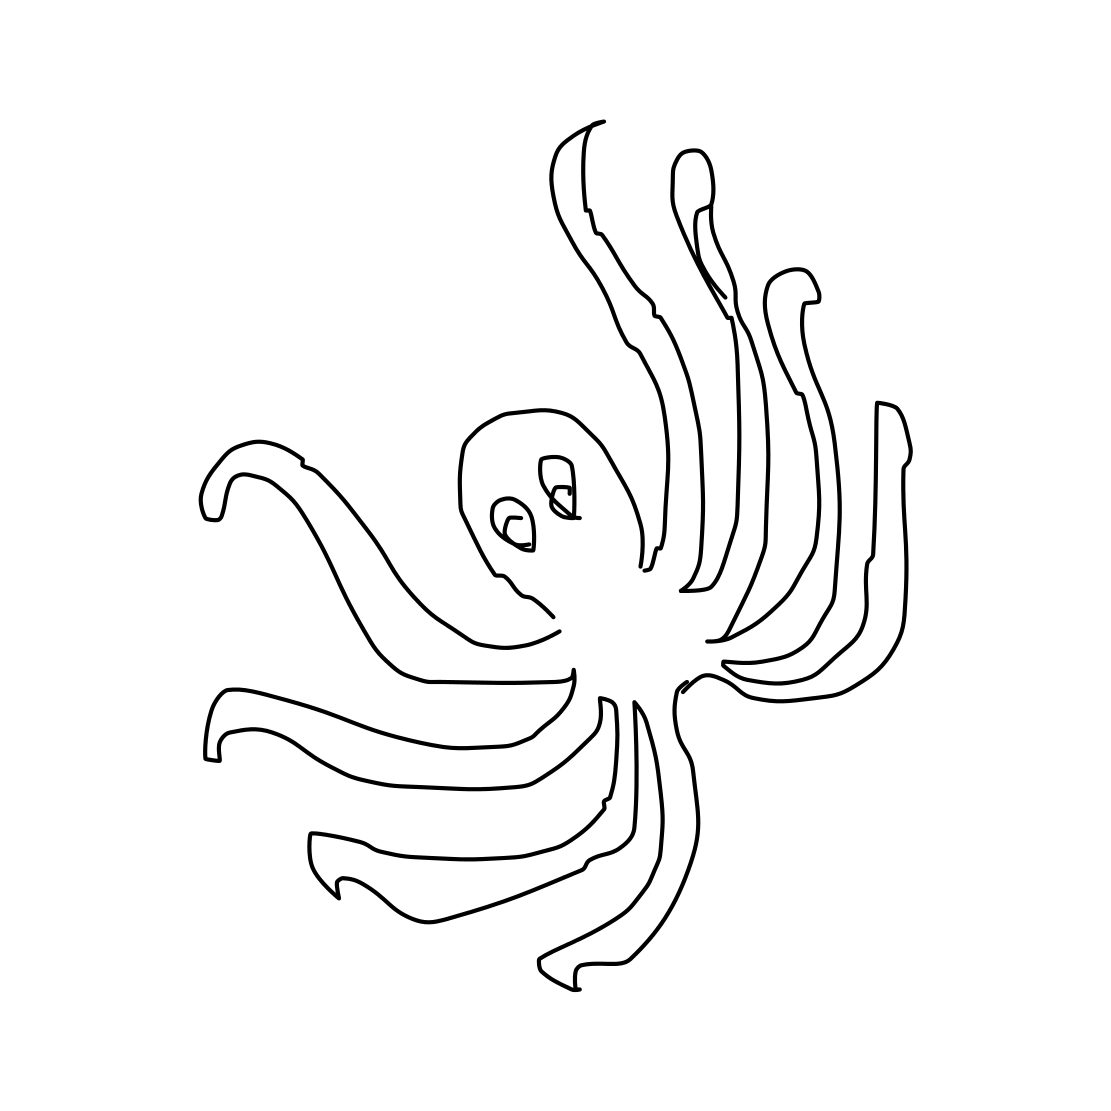What details can you describe about the octopus in the sketch? The octopus sketch is minimalistic, with flowing lines illustrating its tentacles. The eyes are oversized, giving it a somewhat cartoonish look. Each tentacle curls gracefully, suggesting movement and flexibility. 